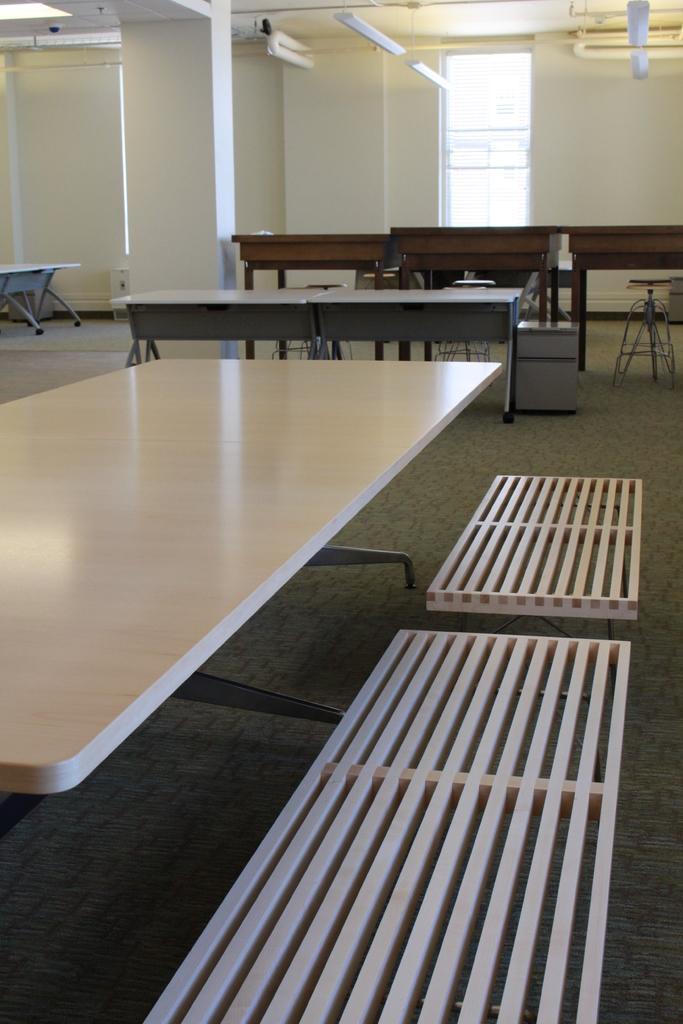Could you give a brief overview of what you see in this image? In this image we can see some tables, benches, lights, rooftop, also we can see the wall, and a window. 